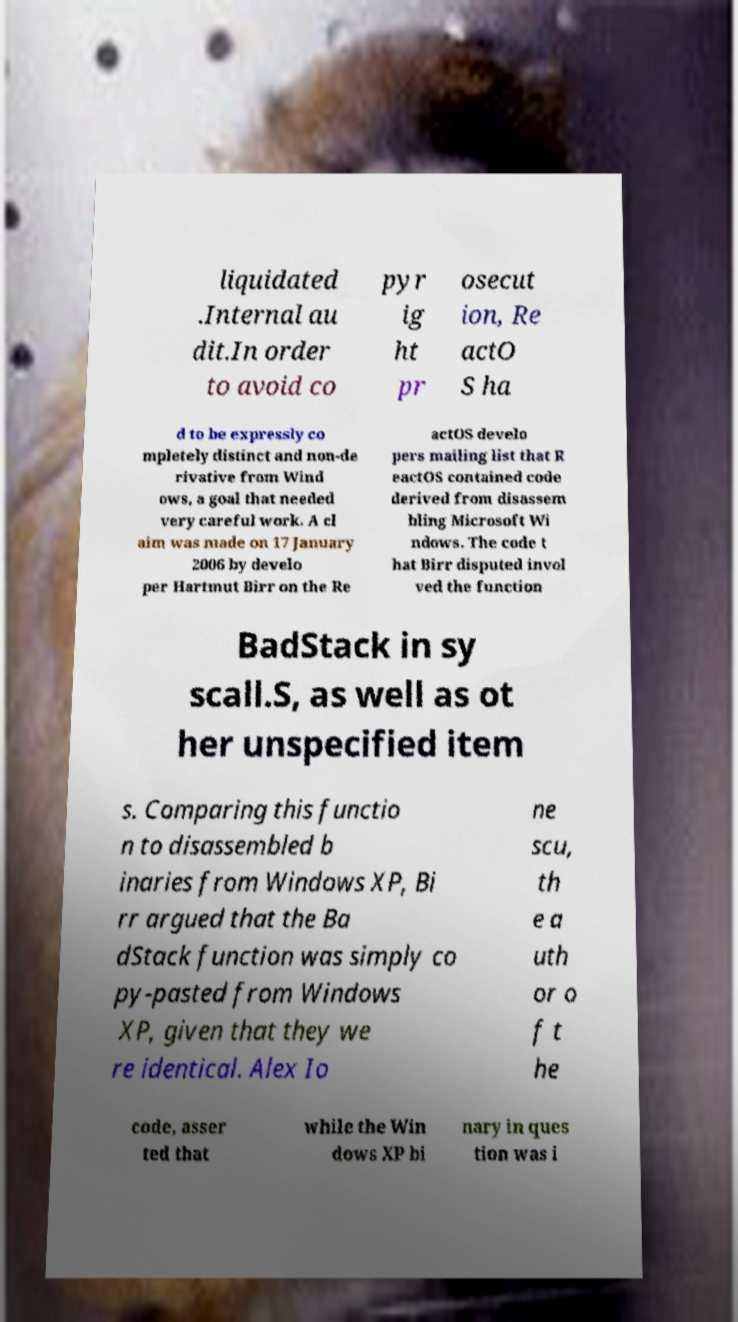Please identify and transcribe the text found in this image. liquidated .Internal au dit.In order to avoid co pyr ig ht pr osecut ion, Re actO S ha d to be expressly co mpletely distinct and non-de rivative from Wind ows, a goal that needed very careful work. A cl aim was made on 17 January 2006 by develo per Hartmut Birr on the Re actOS develo pers mailing list that R eactOS contained code derived from disassem bling Microsoft Wi ndows. The code t hat Birr disputed invol ved the function BadStack in sy scall.S, as well as ot her unspecified item s. Comparing this functio n to disassembled b inaries from Windows XP, Bi rr argued that the Ba dStack function was simply co py-pasted from Windows XP, given that they we re identical. Alex Io ne scu, th e a uth or o f t he code, asser ted that while the Win dows XP bi nary in ques tion was i 